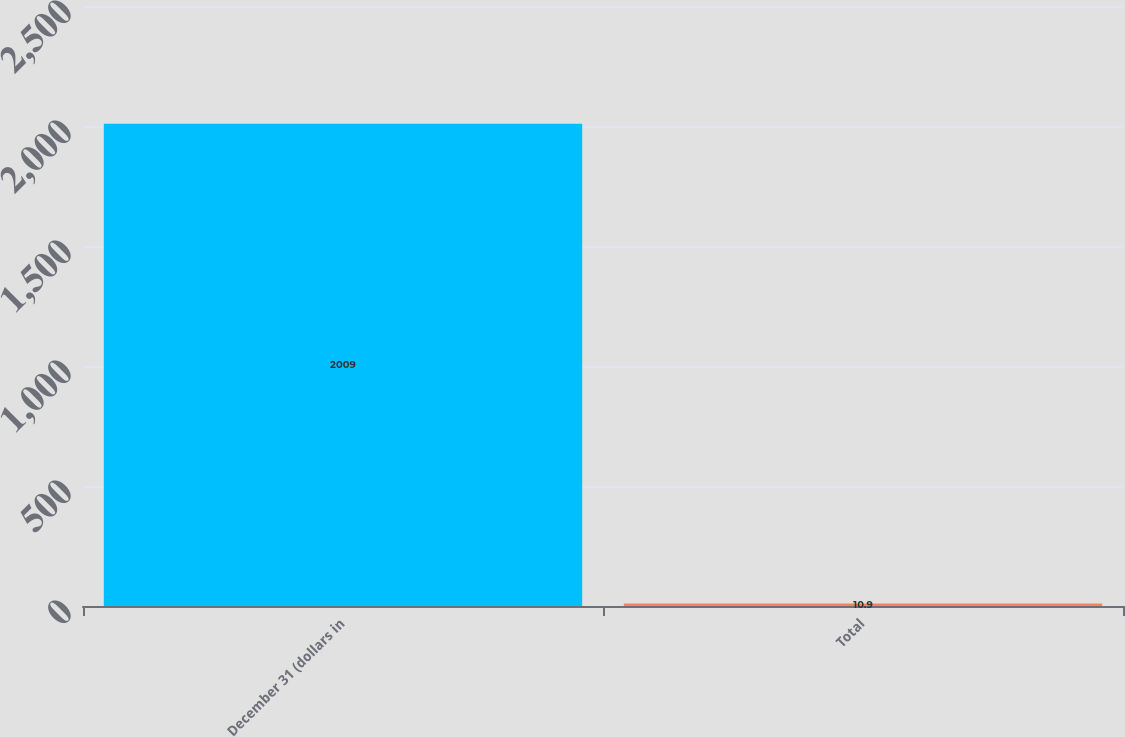Convert chart to OTSL. <chart><loc_0><loc_0><loc_500><loc_500><bar_chart><fcel>December 31 (dollars in<fcel>Total<nl><fcel>2009<fcel>10.9<nl></chart> 